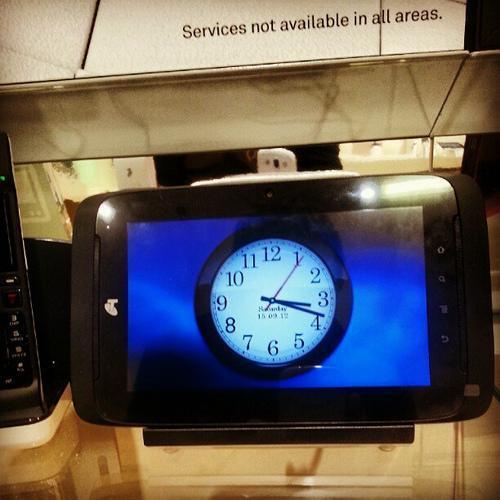How many clocks are there?
Give a very brief answer. 1. 